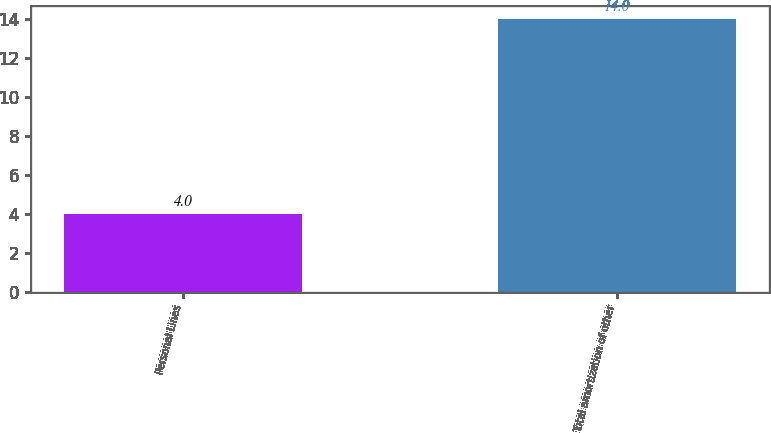Convert chart to OTSL. <chart><loc_0><loc_0><loc_500><loc_500><bar_chart><fcel>Personal Lines<fcel>Total amortization of other<nl><fcel>4<fcel>14<nl></chart> 